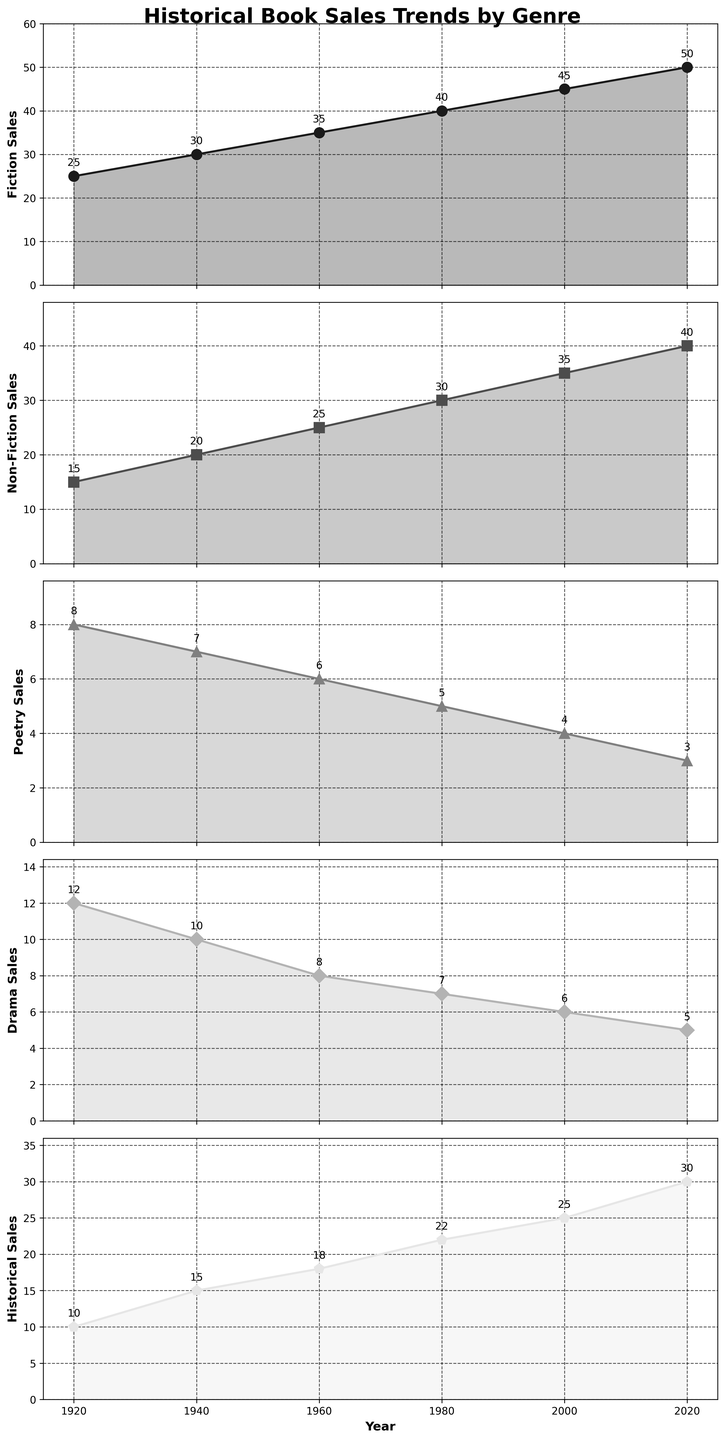What is the title of the figure? The title is usually located at the top of the figure. In this case, it is clearly visible at the top.
Answer: Historical Book Sales Trends by Genre Which genre has the highest sales in 2020? Look at the 2020 data points for each subplot. The genre with the highest sales is the one furthest up the y-axis.
Answer: Fiction What is the range of Non-Fiction book sales from 1920 to 2020? Find the maximum and minimum values for Non-Fiction sales from the subplots. Subtract the minimum value from the maximum value to get the range.
Answer: 40 - 15 = 25 Which genre showed a consistent increase in sales every 20 years? Observe each genre's trendline. A consistent increase means each data point must be higher than the previous one.
Answer: Fiction What is the total book sales for Poetry and Drama in 1980? Locate the points for Poetry and Drama in 1980, and then sum their values.
Answer: 5 (Poetry) + 7 (Drama) = 12 At what year do Non-Fiction and Historical genres have the same sales? Check the subplots for both genres and find the year where their values match.
Answer: 1940 How do the sales trends of Fiction and Poetry compare over the century? Compare the general direction and steepness of the trend lines for Fiction and Poetry. Fiction shows a steady increase, whereas Poetry shows a steady decrease.
Answer: Fiction increases, Poetry decreases What is the difference in sales between the highest and lowest genres in 2000? Identify the genres with the highest and lowest sales in 2000 and then subtract the lowest value from the highest.
Answer: 45 (Fiction) - 4 (Poetry) = 41 In which genre and year can you find an annotated value of ‘30’? Check each subplot for any annotated value of '30'.
Answer: Non-Fiction in 2020 